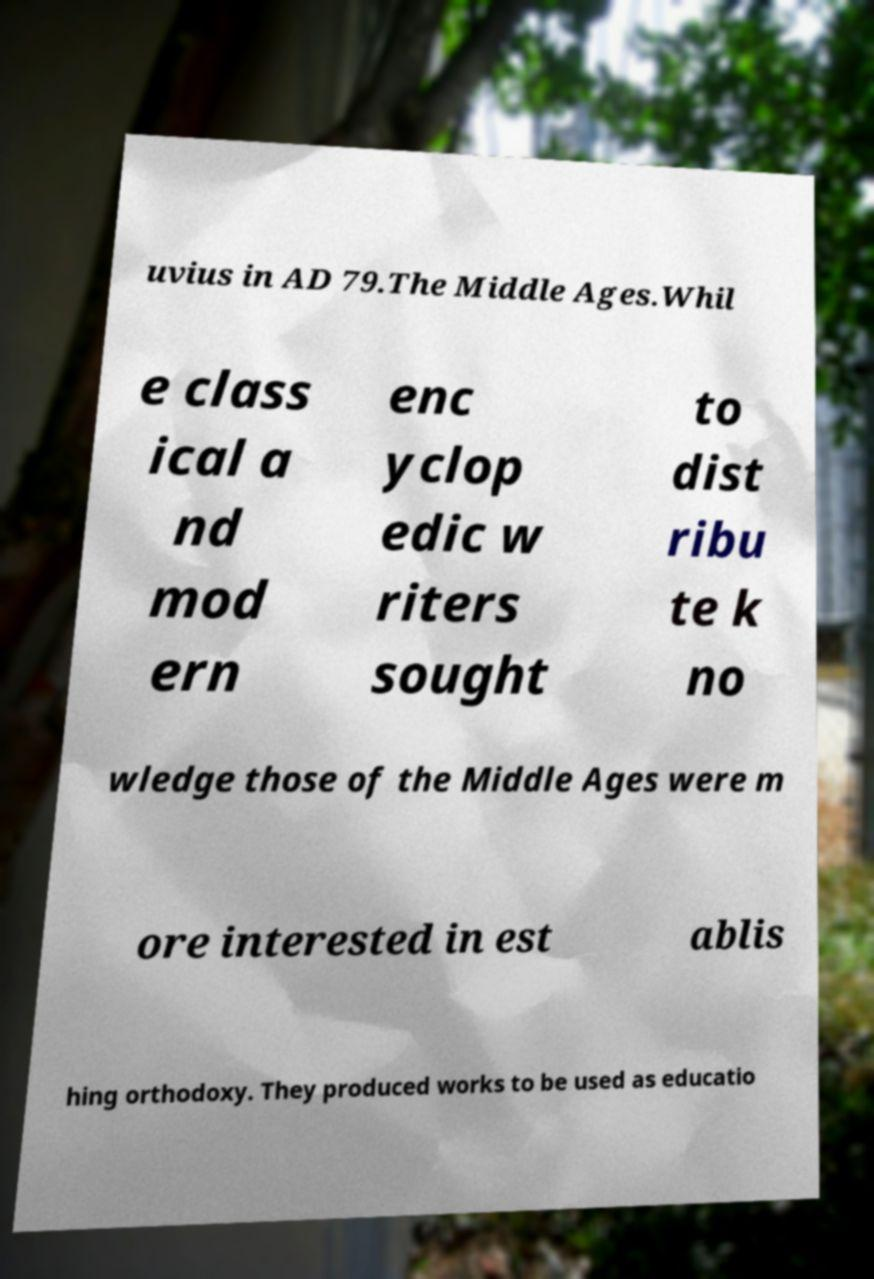For documentation purposes, I need the text within this image transcribed. Could you provide that? uvius in AD 79.The Middle Ages.Whil e class ical a nd mod ern enc yclop edic w riters sought to dist ribu te k no wledge those of the Middle Ages were m ore interested in est ablis hing orthodoxy. They produced works to be used as educatio 